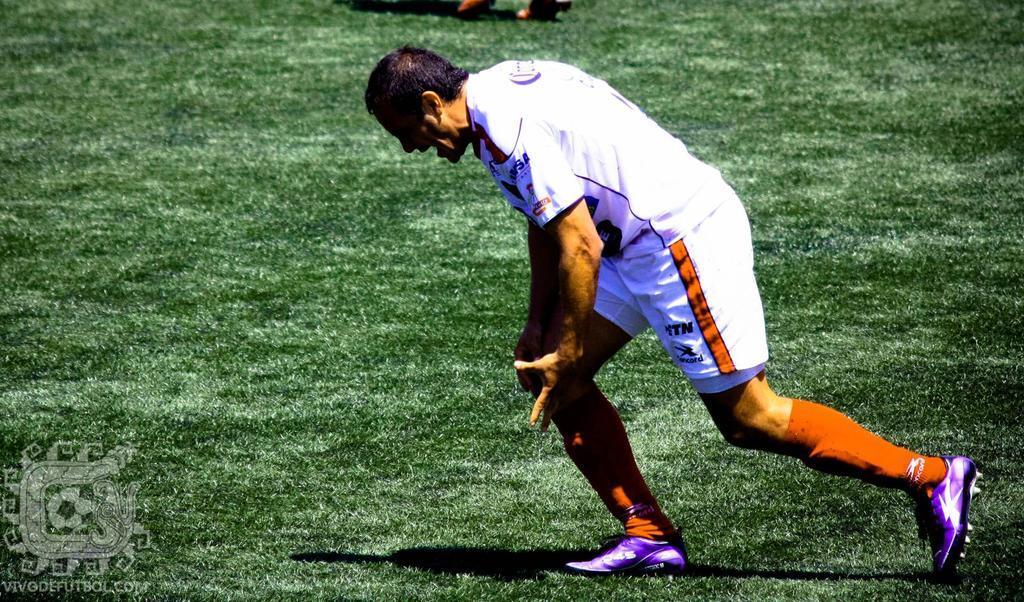Please provide a concise description of this image. In the picture I can see a man is running on the ground. The man is wearing white color clothes and shoes. In the background I can see the grass. I can also see a watermark on the image. 